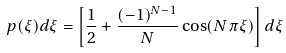<formula> <loc_0><loc_0><loc_500><loc_500>p ( \xi ) d \xi = \left [ \frac { 1 } { 2 } + \frac { ( - 1 ) ^ { N - 1 } } { N } \cos ( N \pi \xi ) \right ] d \xi</formula> 